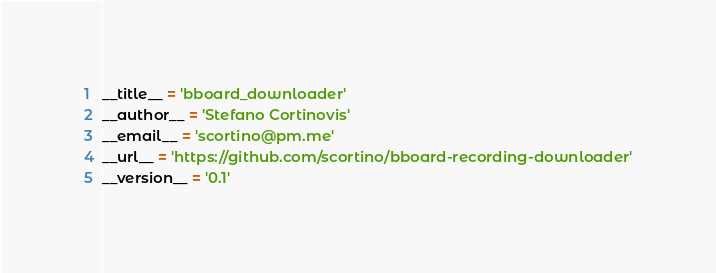<code> <loc_0><loc_0><loc_500><loc_500><_Python_>__title__ = 'bboard_downloader'
__author__ = 'Stefano Cortinovis'
__email__ = 'scortino@pm.me'
__url__ = 'https://github.com/scortino/bboard-recording-downloader'
__version__ = '0.1'</code> 